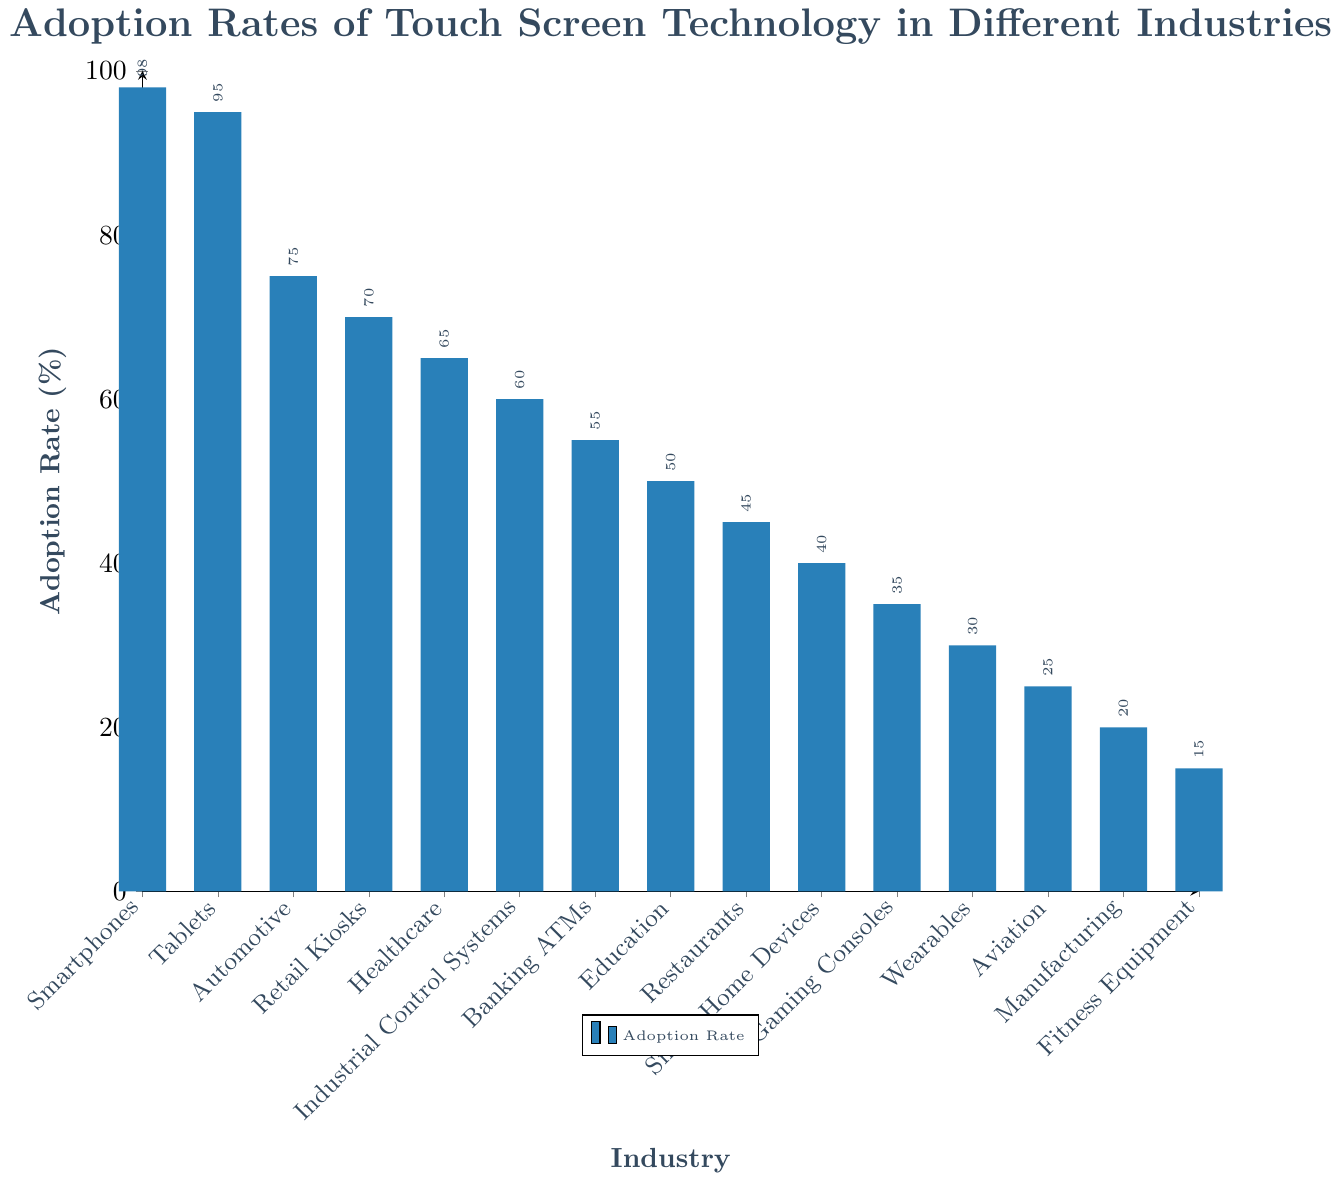What's the industry with the highest adoption rate? Look for the tallest bar in the chart. The Smartphones industry has the highest adoption rate at 98%.
Answer: Smartphones Which two industries have the same adoption rate? Scan the bars for industries with the same height. None of the industries have the same adoption rate in this chart.
Answer: None What's the difference in adoption rates between the Automotive and Manufacturing industries? Identify the bars for Automotive and Manufacturing. The adoption rate for Automotive is 75%, and for Manufacturing, it is 20%. Subtract 20 from 75.
Answer: 55% Which industry has the lowest adoption rate? Look for the shortest bar in the chart. The Fitness Equipment industry has the lowest adoption rate of 15%.
Answer: Fitness Equipment What is the average adoption rate across all industries? Sum all the adoption rates and divide by the number of industries: (98 + 95 + 75 + 70 + 65 + 60 + 55 + 50 + 45 + 40 + 35 + 30 + 25 + 20 + 15) / 15 = 56.67%
Answer: 56.67% How many industries have an adoption rate of 50% or less? Count the bars that are at 50% or below: Education, Restaurants, Smart Home Devices, Gaming Consoles, Wearables, Aviation, Manufacturing, Fitness Equipment. There are 8 industries in total.
Answer: 8 What's the combined adoption rate of Smart Home Devices and Gaming Consoles? Add the adoption rates for Smart Home Devices (40%) and Gaming Consoles (35%).
Answer: 75% Which industry has a higher adoption rate: Healthcare or Retail Kiosks? Compare the bars for Healthcare (65%) and Retail Kiosks (70%). Retail Kiosks has a higher adoption rate.
Answer: Retail Kiosks What is the median adoption rate among the industries? Order the adoption rates and find the middle value: (15, 20, 25, 30, 35, 40, 45, 50, 55, 60, 65, 70, 75, 95, 98). The middle value is 50%.
Answer: 50% By what percentage is the adoption rate in Smartphones higher than in Banking ATMs? The adoption rate in Smartphones is 98%, and in Banking ATMs it is 55%. Calculate ((98 - 55) / 55) * 100.
Answer: 78.18% 